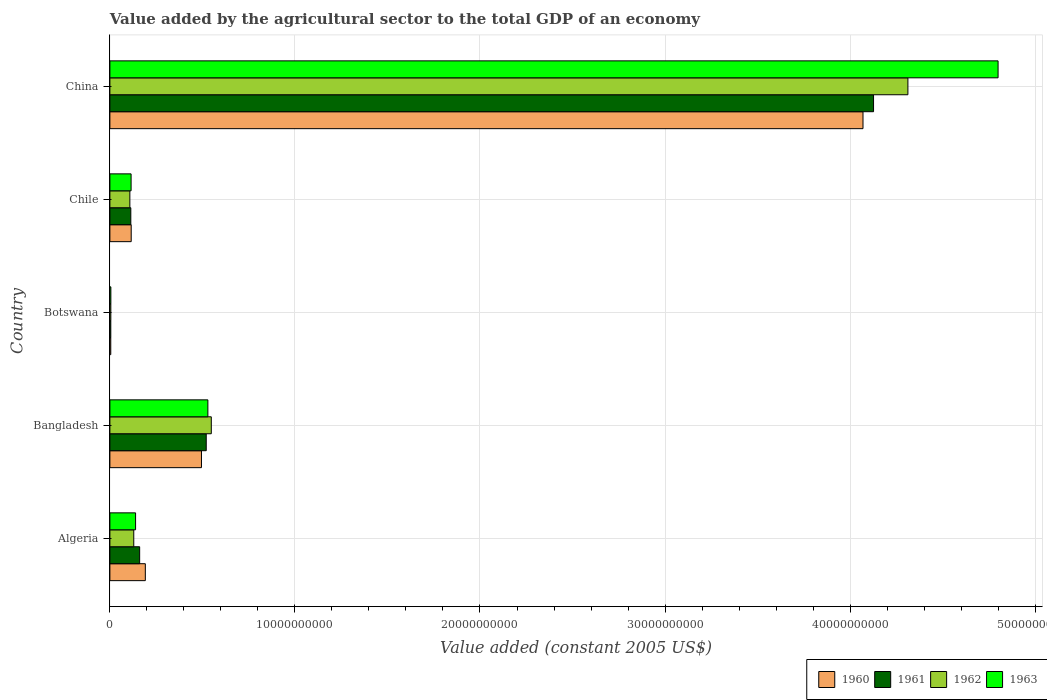How many different coloured bars are there?
Offer a very short reply. 4. How many groups of bars are there?
Your response must be concise. 5. Are the number of bars on each tick of the Y-axis equal?
Provide a short and direct response. Yes. How many bars are there on the 3rd tick from the top?
Provide a succinct answer. 4. What is the label of the 5th group of bars from the top?
Offer a very short reply. Algeria. In how many cases, is the number of bars for a given country not equal to the number of legend labels?
Ensure brevity in your answer.  0. What is the value added by the agricultural sector in 1961 in Botswana?
Provide a short and direct response. 4.86e+07. Across all countries, what is the maximum value added by the agricultural sector in 1962?
Provide a short and direct response. 4.31e+1. Across all countries, what is the minimum value added by the agricultural sector in 1963?
Offer a very short reply. 5.21e+07. In which country was the value added by the agricultural sector in 1960 maximum?
Provide a succinct answer. China. In which country was the value added by the agricultural sector in 1963 minimum?
Provide a succinct answer. Botswana. What is the total value added by the agricultural sector in 1963 in the graph?
Your answer should be compact. 5.59e+1. What is the difference between the value added by the agricultural sector in 1962 in Bangladesh and that in Chile?
Your answer should be compact. 4.40e+09. What is the difference between the value added by the agricultural sector in 1962 in Botswana and the value added by the agricultural sector in 1963 in Chile?
Offer a very short reply. -1.10e+09. What is the average value added by the agricultural sector in 1963 per country?
Offer a terse response. 1.12e+1. What is the difference between the value added by the agricultural sector in 1961 and value added by the agricultural sector in 1963 in China?
Provide a short and direct response. -6.73e+09. In how many countries, is the value added by the agricultural sector in 1963 greater than 48000000000 US$?
Ensure brevity in your answer.  0. What is the ratio of the value added by the agricultural sector in 1962 in Bangladesh to that in Chile?
Give a very brief answer. 5.08. Is the value added by the agricultural sector in 1961 in Algeria less than that in Bangladesh?
Make the answer very short. Yes. What is the difference between the highest and the second highest value added by the agricultural sector in 1963?
Offer a terse response. 4.27e+1. What is the difference between the highest and the lowest value added by the agricultural sector in 1963?
Ensure brevity in your answer.  4.79e+1. Is the sum of the value added by the agricultural sector in 1960 in Algeria and Bangladesh greater than the maximum value added by the agricultural sector in 1961 across all countries?
Ensure brevity in your answer.  No. What does the 2nd bar from the top in Bangladesh represents?
Keep it short and to the point. 1962. What does the 4th bar from the bottom in Chile represents?
Offer a terse response. 1963. Is it the case that in every country, the sum of the value added by the agricultural sector in 1962 and value added by the agricultural sector in 1961 is greater than the value added by the agricultural sector in 1960?
Your response must be concise. Yes. Are all the bars in the graph horizontal?
Offer a very short reply. Yes. Are the values on the major ticks of X-axis written in scientific E-notation?
Make the answer very short. No. How many legend labels are there?
Offer a very short reply. 4. How are the legend labels stacked?
Your response must be concise. Horizontal. What is the title of the graph?
Offer a terse response. Value added by the agricultural sector to the total GDP of an economy. What is the label or title of the X-axis?
Provide a succinct answer. Value added (constant 2005 US$). What is the label or title of the Y-axis?
Provide a succinct answer. Country. What is the Value added (constant 2005 US$) in 1960 in Algeria?
Give a very brief answer. 1.92e+09. What is the Value added (constant 2005 US$) in 1961 in Algeria?
Offer a terse response. 1.61e+09. What is the Value added (constant 2005 US$) of 1962 in Algeria?
Ensure brevity in your answer.  1.29e+09. What is the Value added (constant 2005 US$) of 1963 in Algeria?
Give a very brief answer. 1.39e+09. What is the Value added (constant 2005 US$) of 1960 in Bangladesh?
Offer a very short reply. 4.95e+09. What is the Value added (constant 2005 US$) in 1961 in Bangladesh?
Ensure brevity in your answer.  5.21e+09. What is the Value added (constant 2005 US$) of 1962 in Bangladesh?
Your answer should be compact. 5.48e+09. What is the Value added (constant 2005 US$) in 1963 in Bangladesh?
Offer a terse response. 5.30e+09. What is the Value added (constant 2005 US$) of 1960 in Botswana?
Provide a succinct answer. 4.74e+07. What is the Value added (constant 2005 US$) of 1961 in Botswana?
Keep it short and to the point. 4.86e+07. What is the Value added (constant 2005 US$) of 1962 in Botswana?
Make the answer very short. 5.04e+07. What is the Value added (constant 2005 US$) of 1963 in Botswana?
Provide a succinct answer. 5.21e+07. What is the Value added (constant 2005 US$) of 1960 in Chile?
Offer a terse response. 1.15e+09. What is the Value added (constant 2005 US$) in 1961 in Chile?
Provide a short and direct response. 1.13e+09. What is the Value added (constant 2005 US$) of 1962 in Chile?
Keep it short and to the point. 1.08e+09. What is the Value added (constant 2005 US$) in 1963 in Chile?
Ensure brevity in your answer.  1.15e+09. What is the Value added (constant 2005 US$) in 1960 in China?
Make the answer very short. 4.07e+1. What is the Value added (constant 2005 US$) of 1961 in China?
Offer a very short reply. 4.13e+1. What is the Value added (constant 2005 US$) in 1962 in China?
Ensure brevity in your answer.  4.31e+1. What is the Value added (constant 2005 US$) of 1963 in China?
Give a very brief answer. 4.80e+1. Across all countries, what is the maximum Value added (constant 2005 US$) in 1960?
Give a very brief answer. 4.07e+1. Across all countries, what is the maximum Value added (constant 2005 US$) in 1961?
Keep it short and to the point. 4.13e+1. Across all countries, what is the maximum Value added (constant 2005 US$) of 1962?
Provide a short and direct response. 4.31e+1. Across all countries, what is the maximum Value added (constant 2005 US$) in 1963?
Keep it short and to the point. 4.80e+1. Across all countries, what is the minimum Value added (constant 2005 US$) of 1960?
Offer a very short reply. 4.74e+07. Across all countries, what is the minimum Value added (constant 2005 US$) in 1961?
Give a very brief answer. 4.86e+07. Across all countries, what is the minimum Value added (constant 2005 US$) of 1962?
Provide a short and direct response. 5.04e+07. Across all countries, what is the minimum Value added (constant 2005 US$) of 1963?
Keep it short and to the point. 5.21e+07. What is the total Value added (constant 2005 US$) in 1960 in the graph?
Give a very brief answer. 4.88e+1. What is the total Value added (constant 2005 US$) in 1961 in the graph?
Your response must be concise. 4.93e+1. What is the total Value added (constant 2005 US$) of 1962 in the graph?
Provide a short and direct response. 5.10e+1. What is the total Value added (constant 2005 US$) in 1963 in the graph?
Provide a succinct answer. 5.59e+1. What is the difference between the Value added (constant 2005 US$) in 1960 in Algeria and that in Bangladesh?
Ensure brevity in your answer.  -3.03e+09. What is the difference between the Value added (constant 2005 US$) in 1961 in Algeria and that in Bangladesh?
Make the answer very short. -3.60e+09. What is the difference between the Value added (constant 2005 US$) in 1962 in Algeria and that in Bangladesh?
Ensure brevity in your answer.  -4.19e+09. What is the difference between the Value added (constant 2005 US$) of 1963 in Algeria and that in Bangladesh?
Provide a short and direct response. -3.91e+09. What is the difference between the Value added (constant 2005 US$) in 1960 in Algeria and that in Botswana?
Your answer should be compact. 1.87e+09. What is the difference between the Value added (constant 2005 US$) of 1961 in Algeria and that in Botswana?
Offer a terse response. 1.56e+09. What is the difference between the Value added (constant 2005 US$) of 1962 in Algeria and that in Botswana?
Provide a short and direct response. 1.24e+09. What is the difference between the Value added (constant 2005 US$) in 1963 in Algeria and that in Botswana?
Give a very brief answer. 1.34e+09. What is the difference between the Value added (constant 2005 US$) of 1960 in Algeria and that in Chile?
Keep it short and to the point. 7.63e+08. What is the difference between the Value added (constant 2005 US$) of 1961 in Algeria and that in Chile?
Your answer should be compact. 4.78e+08. What is the difference between the Value added (constant 2005 US$) in 1962 in Algeria and that in Chile?
Keep it short and to the point. 2.11e+08. What is the difference between the Value added (constant 2005 US$) in 1963 in Algeria and that in Chile?
Your answer should be very brief. 2.42e+08. What is the difference between the Value added (constant 2005 US$) in 1960 in Algeria and that in China?
Your answer should be very brief. -3.88e+1. What is the difference between the Value added (constant 2005 US$) of 1961 in Algeria and that in China?
Keep it short and to the point. -3.97e+1. What is the difference between the Value added (constant 2005 US$) in 1962 in Algeria and that in China?
Ensure brevity in your answer.  -4.18e+1. What is the difference between the Value added (constant 2005 US$) in 1963 in Algeria and that in China?
Provide a short and direct response. -4.66e+1. What is the difference between the Value added (constant 2005 US$) in 1960 in Bangladesh and that in Botswana?
Your response must be concise. 4.90e+09. What is the difference between the Value added (constant 2005 US$) in 1961 in Bangladesh and that in Botswana?
Give a very brief answer. 5.16e+09. What is the difference between the Value added (constant 2005 US$) of 1962 in Bangladesh and that in Botswana?
Offer a terse response. 5.43e+09. What is the difference between the Value added (constant 2005 US$) of 1963 in Bangladesh and that in Botswana?
Ensure brevity in your answer.  5.24e+09. What is the difference between the Value added (constant 2005 US$) of 1960 in Bangladesh and that in Chile?
Your response must be concise. 3.80e+09. What is the difference between the Value added (constant 2005 US$) of 1961 in Bangladesh and that in Chile?
Your answer should be compact. 4.08e+09. What is the difference between the Value added (constant 2005 US$) in 1962 in Bangladesh and that in Chile?
Give a very brief answer. 4.40e+09. What is the difference between the Value added (constant 2005 US$) of 1963 in Bangladesh and that in Chile?
Your response must be concise. 4.15e+09. What is the difference between the Value added (constant 2005 US$) of 1960 in Bangladesh and that in China?
Make the answer very short. -3.57e+1. What is the difference between the Value added (constant 2005 US$) in 1961 in Bangladesh and that in China?
Offer a very short reply. -3.61e+1. What is the difference between the Value added (constant 2005 US$) of 1962 in Bangladesh and that in China?
Offer a terse response. -3.76e+1. What is the difference between the Value added (constant 2005 US$) in 1963 in Bangladesh and that in China?
Your answer should be compact. -4.27e+1. What is the difference between the Value added (constant 2005 US$) in 1960 in Botswana and that in Chile?
Your answer should be very brief. -1.10e+09. What is the difference between the Value added (constant 2005 US$) in 1961 in Botswana and that in Chile?
Your answer should be very brief. -1.08e+09. What is the difference between the Value added (constant 2005 US$) in 1962 in Botswana and that in Chile?
Give a very brief answer. -1.03e+09. What is the difference between the Value added (constant 2005 US$) of 1963 in Botswana and that in Chile?
Make the answer very short. -1.09e+09. What is the difference between the Value added (constant 2005 US$) in 1960 in Botswana and that in China?
Keep it short and to the point. -4.07e+1. What is the difference between the Value added (constant 2005 US$) of 1961 in Botswana and that in China?
Your response must be concise. -4.12e+1. What is the difference between the Value added (constant 2005 US$) of 1962 in Botswana and that in China?
Give a very brief answer. -4.31e+1. What is the difference between the Value added (constant 2005 US$) in 1963 in Botswana and that in China?
Your answer should be compact. -4.79e+1. What is the difference between the Value added (constant 2005 US$) in 1960 in Chile and that in China?
Give a very brief answer. -3.95e+1. What is the difference between the Value added (constant 2005 US$) of 1961 in Chile and that in China?
Keep it short and to the point. -4.01e+1. What is the difference between the Value added (constant 2005 US$) of 1962 in Chile and that in China?
Offer a terse response. -4.20e+1. What is the difference between the Value added (constant 2005 US$) of 1963 in Chile and that in China?
Provide a succinct answer. -4.69e+1. What is the difference between the Value added (constant 2005 US$) in 1960 in Algeria and the Value added (constant 2005 US$) in 1961 in Bangladesh?
Give a very brief answer. -3.29e+09. What is the difference between the Value added (constant 2005 US$) in 1960 in Algeria and the Value added (constant 2005 US$) in 1962 in Bangladesh?
Make the answer very short. -3.56e+09. What is the difference between the Value added (constant 2005 US$) of 1960 in Algeria and the Value added (constant 2005 US$) of 1963 in Bangladesh?
Your response must be concise. -3.38e+09. What is the difference between the Value added (constant 2005 US$) in 1961 in Algeria and the Value added (constant 2005 US$) in 1962 in Bangladesh?
Ensure brevity in your answer.  -3.87e+09. What is the difference between the Value added (constant 2005 US$) of 1961 in Algeria and the Value added (constant 2005 US$) of 1963 in Bangladesh?
Provide a succinct answer. -3.69e+09. What is the difference between the Value added (constant 2005 US$) of 1962 in Algeria and the Value added (constant 2005 US$) of 1963 in Bangladesh?
Offer a very short reply. -4.00e+09. What is the difference between the Value added (constant 2005 US$) in 1960 in Algeria and the Value added (constant 2005 US$) in 1961 in Botswana?
Offer a very short reply. 1.87e+09. What is the difference between the Value added (constant 2005 US$) of 1960 in Algeria and the Value added (constant 2005 US$) of 1962 in Botswana?
Your answer should be very brief. 1.86e+09. What is the difference between the Value added (constant 2005 US$) of 1960 in Algeria and the Value added (constant 2005 US$) of 1963 in Botswana?
Make the answer very short. 1.86e+09. What is the difference between the Value added (constant 2005 US$) of 1961 in Algeria and the Value added (constant 2005 US$) of 1962 in Botswana?
Offer a very short reply. 1.56e+09. What is the difference between the Value added (constant 2005 US$) of 1961 in Algeria and the Value added (constant 2005 US$) of 1963 in Botswana?
Make the answer very short. 1.56e+09. What is the difference between the Value added (constant 2005 US$) of 1962 in Algeria and the Value added (constant 2005 US$) of 1963 in Botswana?
Keep it short and to the point. 1.24e+09. What is the difference between the Value added (constant 2005 US$) of 1960 in Algeria and the Value added (constant 2005 US$) of 1961 in Chile?
Offer a terse response. 7.85e+08. What is the difference between the Value added (constant 2005 US$) in 1960 in Algeria and the Value added (constant 2005 US$) in 1962 in Chile?
Make the answer very short. 8.36e+08. What is the difference between the Value added (constant 2005 US$) of 1960 in Algeria and the Value added (constant 2005 US$) of 1963 in Chile?
Your response must be concise. 7.69e+08. What is the difference between the Value added (constant 2005 US$) of 1961 in Algeria and the Value added (constant 2005 US$) of 1962 in Chile?
Provide a succinct answer. 5.29e+08. What is the difference between the Value added (constant 2005 US$) in 1961 in Algeria and the Value added (constant 2005 US$) in 1963 in Chile?
Offer a terse response. 4.62e+08. What is the difference between the Value added (constant 2005 US$) in 1962 in Algeria and the Value added (constant 2005 US$) in 1963 in Chile?
Your answer should be compact. 1.44e+08. What is the difference between the Value added (constant 2005 US$) in 1960 in Algeria and the Value added (constant 2005 US$) in 1961 in China?
Offer a very short reply. -3.94e+1. What is the difference between the Value added (constant 2005 US$) in 1960 in Algeria and the Value added (constant 2005 US$) in 1962 in China?
Your answer should be compact. -4.12e+1. What is the difference between the Value added (constant 2005 US$) in 1960 in Algeria and the Value added (constant 2005 US$) in 1963 in China?
Give a very brief answer. -4.61e+1. What is the difference between the Value added (constant 2005 US$) in 1961 in Algeria and the Value added (constant 2005 US$) in 1962 in China?
Your answer should be compact. -4.15e+1. What is the difference between the Value added (constant 2005 US$) in 1961 in Algeria and the Value added (constant 2005 US$) in 1963 in China?
Your answer should be very brief. -4.64e+1. What is the difference between the Value added (constant 2005 US$) of 1962 in Algeria and the Value added (constant 2005 US$) of 1963 in China?
Ensure brevity in your answer.  -4.67e+1. What is the difference between the Value added (constant 2005 US$) of 1960 in Bangladesh and the Value added (constant 2005 US$) of 1961 in Botswana?
Your answer should be compact. 4.90e+09. What is the difference between the Value added (constant 2005 US$) in 1960 in Bangladesh and the Value added (constant 2005 US$) in 1962 in Botswana?
Your response must be concise. 4.90e+09. What is the difference between the Value added (constant 2005 US$) in 1960 in Bangladesh and the Value added (constant 2005 US$) in 1963 in Botswana?
Give a very brief answer. 4.90e+09. What is the difference between the Value added (constant 2005 US$) of 1961 in Bangladesh and the Value added (constant 2005 US$) of 1962 in Botswana?
Ensure brevity in your answer.  5.16e+09. What is the difference between the Value added (constant 2005 US$) of 1961 in Bangladesh and the Value added (constant 2005 US$) of 1963 in Botswana?
Keep it short and to the point. 5.15e+09. What is the difference between the Value added (constant 2005 US$) of 1962 in Bangladesh and the Value added (constant 2005 US$) of 1963 in Botswana?
Give a very brief answer. 5.43e+09. What is the difference between the Value added (constant 2005 US$) in 1960 in Bangladesh and the Value added (constant 2005 US$) in 1961 in Chile?
Provide a short and direct response. 3.82e+09. What is the difference between the Value added (constant 2005 US$) of 1960 in Bangladesh and the Value added (constant 2005 US$) of 1962 in Chile?
Offer a very short reply. 3.87e+09. What is the difference between the Value added (constant 2005 US$) in 1960 in Bangladesh and the Value added (constant 2005 US$) in 1963 in Chile?
Provide a succinct answer. 3.80e+09. What is the difference between the Value added (constant 2005 US$) in 1961 in Bangladesh and the Value added (constant 2005 US$) in 1962 in Chile?
Offer a terse response. 4.13e+09. What is the difference between the Value added (constant 2005 US$) of 1961 in Bangladesh and the Value added (constant 2005 US$) of 1963 in Chile?
Your answer should be compact. 4.06e+09. What is the difference between the Value added (constant 2005 US$) of 1962 in Bangladesh and the Value added (constant 2005 US$) of 1963 in Chile?
Your answer should be very brief. 4.33e+09. What is the difference between the Value added (constant 2005 US$) in 1960 in Bangladesh and the Value added (constant 2005 US$) in 1961 in China?
Make the answer very short. -3.63e+1. What is the difference between the Value added (constant 2005 US$) in 1960 in Bangladesh and the Value added (constant 2005 US$) in 1962 in China?
Your answer should be very brief. -3.82e+1. What is the difference between the Value added (constant 2005 US$) of 1960 in Bangladesh and the Value added (constant 2005 US$) of 1963 in China?
Provide a succinct answer. -4.30e+1. What is the difference between the Value added (constant 2005 US$) of 1961 in Bangladesh and the Value added (constant 2005 US$) of 1962 in China?
Your answer should be compact. -3.79e+1. What is the difference between the Value added (constant 2005 US$) in 1961 in Bangladesh and the Value added (constant 2005 US$) in 1963 in China?
Your answer should be compact. -4.28e+1. What is the difference between the Value added (constant 2005 US$) in 1962 in Bangladesh and the Value added (constant 2005 US$) in 1963 in China?
Keep it short and to the point. -4.25e+1. What is the difference between the Value added (constant 2005 US$) of 1960 in Botswana and the Value added (constant 2005 US$) of 1961 in Chile?
Your answer should be very brief. -1.08e+09. What is the difference between the Value added (constant 2005 US$) of 1960 in Botswana and the Value added (constant 2005 US$) of 1962 in Chile?
Keep it short and to the point. -1.03e+09. What is the difference between the Value added (constant 2005 US$) of 1960 in Botswana and the Value added (constant 2005 US$) of 1963 in Chile?
Your answer should be very brief. -1.10e+09. What is the difference between the Value added (constant 2005 US$) in 1961 in Botswana and the Value added (constant 2005 US$) in 1962 in Chile?
Offer a terse response. -1.03e+09. What is the difference between the Value added (constant 2005 US$) in 1961 in Botswana and the Value added (constant 2005 US$) in 1963 in Chile?
Your answer should be very brief. -1.10e+09. What is the difference between the Value added (constant 2005 US$) in 1962 in Botswana and the Value added (constant 2005 US$) in 1963 in Chile?
Offer a terse response. -1.10e+09. What is the difference between the Value added (constant 2005 US$) in 1960 in Botswana and the Value added (constant 2005 US$) in 1961 in China?
Your response must be concise. -4.12e+1. What is the difference between the Value added (constant 2005 US$) of 1960 in Botswana and the Value added (constant 2005 US$) of 1962 in China?
Offer a terse response. -4.31e+1. What is the difference between the Value added (constant 2005 US$) in 1960 in Botswana and the Value added (constant 2005 US$) in 1963 in China?
Give a very brief answer. -4.80e+1. What is the difference between the Value added (constant 2005 US$) of 1961 in Botswana and the Value added (constant 2005 US$) of 1962 in China?
Ensure brevity in your answer.  -4.31e+1. What is the difference between the Value added (constant 2005 US$) in 1961 in Botswana and the Value added (constant 2005 US$) in 1963 in China?
Give a very brief answer. -4.79e+1. What is the difference between the Value added (constant 2005 US$) in 1962 in Botswana and the Value added (constant 2005 US$) in 1963 in China?
Give a very brief answer. -4.79e+1. What is the difference between the Value added (constant 2005 US$) of 1960 in Chile and the Value added (constant 2005 US$) of 1961 in China?
Keep it short and to the point. -4.01e+1. What is the difference between the Value added (constant 2005 US$) in 1960 in Chile and the Value added (constant 2005 US$) in 1962 in China?
Your answer should be compact. -4.20e+1. What is the difference between the Value added (constant 2005 US$) in 1960 in Chile and the Value added (constant 2005 US$) in 1963 in China?
Keep it short and to the point. -4.68e+1. What is the difference between the Value added (constant 2005 US$) of 1961 in Chile and the Value added (constant 2005 US$) of 1962 in China?
Keep it short and to the point. -4.20e+1. What is the difference between the Value added (constant 2005 US$) in 1961 in Chile and the Value added (constant 2005 US$) in 1963 in China?
Your answer should be compact. -4.69e+1. What is the difference between the Value added (constant 2005 US$) in 1962 in Chile and the Value added (constant 2005 US$) in 1963 in China?
Offer a terse response. -4.69e+1. What is the average Value added (constant 2005 US$) of 1960 per country?
Your answer should be compact. 9.75e+09. What is the average Value added (constant 2005 US$) in 1961 per country?
Give a very brief answer. 9.85e+09. What is the average Value added (constant 2005 US$) in 1962 per country?
Make the answer very short. 1.02e+1. What is the average Value added (constant 2005 US$) in 1963 per country?
Offer a terse response. 1.12e+1. What is the difference between the Value added (constant 2005 US$) of 1960 and Value added (constant 2005 US$) of 1961 in Algeria?
Offer a very short reply. 3.07e+08. What is the difference between the Value added (constant 2005 US$) of 1960 and Value added (constant 2005 US$) of 1962 in Algeria?
Provide a short and direct response. 6.25e+08. What is the difference between the Value added (constant 2005 US$) in 1960 and Value added (constant 2005 US$) in 1963 in Algeria?
Provide a succinct answer. 5.27e+08. What is the difference between the Value added (constant 2005 US$) in 1961 and Value added (constant 2005 US$) in 1962 in Algeria?
Ensure brevity in your answer.  3.18e+08. What is the difference between the Value added (constant 2005 US$) of 1961 and Value added (constant 2005 US$) of 1963 in Algeria?
Offer a very short reply. 2.20e+08. What is the difference between the Value added (constant 2005 US$) in 1962 and Value added (constant 2005 US$) in 1963 in Algeria?
Make the answer very short. -9.79e+07. What is the difference between the Value added (constant 2005 US$) of 1960 and Value added (constant 2005 US$) of 1961 in Bangladesh?
Provide a succinct answer. -2.58e+08. What is the difference between the Value added (constant 2005 US$) of 1960 and Value added (constant 2005 US$) of 1962 in Bangladesh?
Your answer should be compact. -5.31e+08. What is the difference between the Value added (constant 2005 US$) of 1960 and Value added (constant 2005 US$) of 1963 in Bangladesh?
Your answer should be very brief. -3.47e+08. What is the difference between the Value added (constant 2005 US$) of 1961 and Value added (constant 2005 US$) of 1962 in Bangladesh?
Your response must be concise. -2.73e+08. What is the difference between the Value added (constant 2005 US$) of 1961 and Value added (constant 2005 US$) of 1963 in Bangladesh?
Make the answer very short. -8.88e+07. What is the difference between the Value added (constant 2005 US$) in 1962 and Value added (constant 2005 US$) in 1963 in Bangladesh?
Give a very brief answer. 1.84e+08. What is the difference between the Value added (constant 2005 US$) in 1960 and Value added (constant 2005 US$) in 1961 in Botswana?
Offer a terse response. -1.17e+06. What is the difference between the Value added (constant 2005 US$) of 1960 and Value added (constant 2005 US$) of 1962 in Botswana?
Your answer should be compact. -2.92e+06. What is the difference between the Value added (constant 2005 US$) in 1960 and Value added (constant 2005 US$) in 1963 in Botswana?
Your answer should be very brief. -4.67e+06. What is the difference between the Value added (constant 2005 US$) in 1961 and Value added (constant 2005 US$) in 1962 in Botswana?
Your answer should be very brief. -1.75e+06. What is the difference between the Value added (constant 2005 US$) in 1961 and Value added (constant 2005 US$) in 1963 in Botswana?
Make the answer very short. -3.51e+06. What is the difference between the Value added (constant 2005 US$) in 1962 and Value added (constant 2005 US$) in 1963 in Botswana?
Your answer should be compact. -1.75e+06. What is the difference between the Value added (constant 2005 US$) in 1960 and Value added (constant 2005 US$) in 1961 in Chile?
Offer a terse response. 2.12e+07. What is the difference between the Value added (constant 2005 US$) in 1960 and Value added (constant 2005 US$) in 1962 in Chile?
Give a very brief answer. 7.27e+07. What is the difference between the Value added (constant 2005 US$) of 1960 and Value added (constant 2005 US$) of 1963 in Chile?
Your response must be concise. 5.74e+06. What is the difference between the Value added (constant 2005 US$) in 1961 and Value added (constant 2005 US$) in 1962 in Chile?
Your answer should be compact. 5.15e+07. What is the difference between the Value added (constant 2005 US$) of 1961 and Value added (constant 2005 US$) of 1963 in Chile?
Give a very brief answer. -1.54e+07. What is the difference between the Value added (constant 2005 US$) of 1962 and Value added (constant 2005 US$) of 1963 in Chile?
Provide a succinct answer. -6.69e+07. What is the difference between the Value added (constant 2005 US$) in 1960 and Value added (constant 2005 US$) in 1961 in China?
Make the answer very short. -5.70e+08. What is the difference between the Value added (constant 2005 US$) of 1960 and Value added (constant 2005 US$) of 1962 in China?
Your answer should be compact. -2.43e+09. What is the difference between the Value added (constant 2005 US$) in 1960 and Value added (constant 2005 US$) in 1963 in China?
Provide a succinct answer. -7.30e+09. What is the difference between the Value added (constant 2005 US$) in 1961 and Value added (constant 2005 US$) in 1962 in China?
Your response must be concise. -1.86e+09. What is the difference between the Value added (constant 2005 US$) in 1961 and Value added (constant 2005 US$) in 1963 in China?
Your response must be concise. -6.73e+09. What is the difference between the Value added (constant 2005 US$) of 1962 and Value added (constant 2005 US$) of 1963 in China?
Make the answer very short. -4.87e+09. What is the ratio of the Value added (constant 2005 US$) in 1960 in Algeria to that in Bangladesh?
Ensure brevity in your answer.  0.39. What is the ratio of the Value added (constant 2005 US$) in 1961 in Algeria to that in Bangladesh?
Provide a succinct answer. 0.31. What is the ratio of the Value added (constant 2005 US$) of 1962 in Algeria to that in Bangladesh?
Offer a very short reply. 0.24. What is the ratio of the Value added (constant 2005 US$) of 1963 in Algeria to that in Bangladesh?
Offer a very short reply. 0.26. What is the ratio of the Value added (constant 2005 US$) of 1960 in Algeria to that in Botswana?
Provide a short and direct response. 40.37. What is the ratio of the Value added (constant 2005 US$) in 1961 in Algeria to that in Botswana?
Keep it short and to the point. 33.08. What is the ratio of the Value added (constant 2005 US$) in 1962 in Algeria to that in Botswana?
Keep it short and to the point. 25.62. What is the ratio of the Value added (constant 2005 US$) of 1963 in Algeria to that in Botswana?
Give a very brief answer. 26.63. What is the ratio of the Value added (constant 2005 US$) in 1960 in Algeria to that in Chile?
Your response must be concise. 1.66. What is the ratio of the Value added (constant 2005 US$) in 1961 in Algeria to that in Chile?
Provide a succinct answer. 1.42. What is the ratio of the Value added (constant 2005 US$) of 1962 in Algeria to that in Chile?
Give a very brief answer. 1.2. What is the ratio of the Value added (constant 2005 US$) in 1963 in Algeria to that in Chile?
Your answer should be compact. 1.21. What is the ratio of the Value added (constant 2005 US$) in 1960 in Algeria to that in China?
Give a very brief answer. 0.05. What is the ratio of the Value added (constant 2005 US$) of 1961 in Algeria to that in China?
Offer a very short reply. 0.04. What is the ratio of the Value added (constant 2005 US$) in 1962 in Algeria to that in China?
Keep it short and to the point. 0.03. What is the ratio of the Value added (constant 2005 US$) in 1963 in Algeria to that in China?
Make the answer very short. 0.03. What is the ratio of the Value added (constant 2005 US$) of 1960 in Bangladesh to that in Botswana?
Your response must be concise. 104.3. What is the ratio of the Value added (constant 2005 US$) in 1961 in Bangladesh to that in Botswana?
Offer a very short reply. 107.09. What is the ratio of the Value added (constant 2005 US$) in 1962 in Bangladesh to that in Botswana?
Ensure brevity in your answer.  108.79. What is the ratio of the Value added (constant 2005 US$) of 1963 in Bangladesh to that in Botswana?
Offer a terse response. 101.59. What is the ratio of the Value added (constant 2005 US$) in 1960 in Bangladesh to that in Chile?
Ensure brevity in your answer.  4.3. What is the ratio of the Value added (constant 2005 US$) in 1961 in Bangladesh to that in Chile?
Offer a very short reply. 4.6. What is the ratio of the Value added (constant 2005 US$) in 1962 in Bangladesh to that in Chile?
Offer a very short reply. 5.08. What is the ratio of the Value added (constant 2005 US$) of 1963 in Bangladesh to that in Chile?
Provide a succinct answer. 4.62. What is the ratio of the Value added (constant 2005 US$) in 1960 in Bangladesh to that in China?
Offer a very short reply. 0.12. What is the ratio of the Value added (constant 2005 US$) in 1961 in Bangladesh to that in China?
Provide a short and direct response. 0.13. What is the ratio of the Value added (constant 2005 US$) of 1962 in Bangladesh to that in China?
Your response must be concise. 0.13. What is the ratio of the Value added (constant 2005 US$) of 1963 in Bangladesh to that in China?
Offer a terse response. 0.11. What is the ratio of the Value added (constant 2005 US$) in 1960 in Botswana to that in Chile?
Your answer should be very brief. 0.04. What is the ratio of the Value added (constant 2005 US$) of 1961 in Botswana to that in Chile?
Your response must be concise. 0.04. What is the ratio of the Value added (constant 2005 US$) in 1962 in Botswana to that in Chile?
Provide a short and direct response. 0.05. What is the ratio of the Value added (constant 2005 US$) in 1963 in Botswana to that in Chile?
Your response must be concise. 0.05. What is the ratio of the Value added (constant 2005 US$) in 1960 in Botswana to that in China?
Ensure brevity in your answer.  0. What is the ratio of the Value added (constant 2005 US$) of 1961 in Botswana to that in China?
Provide a short and direct response. 0. What is the ratio of the Value added (constant 2005 US$) of 1962 in Botswana to that in China?
Offer a very short reply. 0. What is the ratio of the Value added (constant 2005 US$) in 1963 in Botswana to that in China?
Your answer should be very brief. 0. What is the ratio of the Value added (constant 2005 US$) in 1960 in Chile to that in China?
Offer a terse response. 0.03. What is the ratio of the Value added (constant 2005 US$) in 1961 in Chile to that in China?
Keep it short and to the point. 0.03. What is the ratio of the Value added (constant 2005 US$) in 1962 in Chile to that in China?
Provide a succinct answer. 0.03. What is the ratio of the Value added (constant 2005 US$) of 1963 in Chile to that in China?
Offer a terse response. 0.02. What is the difference between the highest and the second highest Value added (constant 2005 US$) of 1960?
Your response must be concise. 3.57e+1. What is the difference between the highest and the second highest Value added (constant 2005 US$) in 1961?
Offer a very short reply. 3.61e+1. What is the difference between the highest and the second highest Value added (constant 2005 US$) in 1962?
Your answer should be very brief. 3.76e+1. What is the difference between the highest and the second highest Value added (constant 2005 US$) of 1963?
Your answer should be very brief. 4.27e+1. What is the difference between the highest and the lowest Value added (constant 2005 US$) of 1960?
Your answer should be very brief. 4.07e+1. What is the difference between the highest and the lowest Value added (constant 2005 US$) of 1961?
Ensure brevity in your answer.  4.12e+1. What is the difference between the highest and the lowest Value added (constant 2005 US$) in 1962?
Your answer should be very brief. 4.31e+1. What is the difference between the highest and the lowest Value added (constant 2005 US$) in 1963?
Offer a terse response. 4.79e+1. 